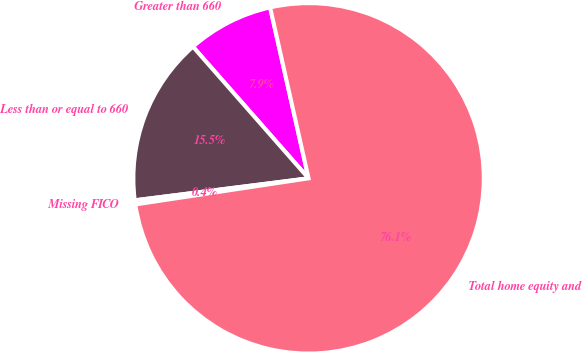<chart> <loc_0><loc_0><loc_500><loc_500><pie_chart><fcel>Greater than 660<fcel>Less than or equal to 660<fcel>Missing FICO<fcel>Total home equity and<nl><fcel>7.95%<fcel>15.53%<fcel>0.38%<fcel>76.14%<nl></chart> 